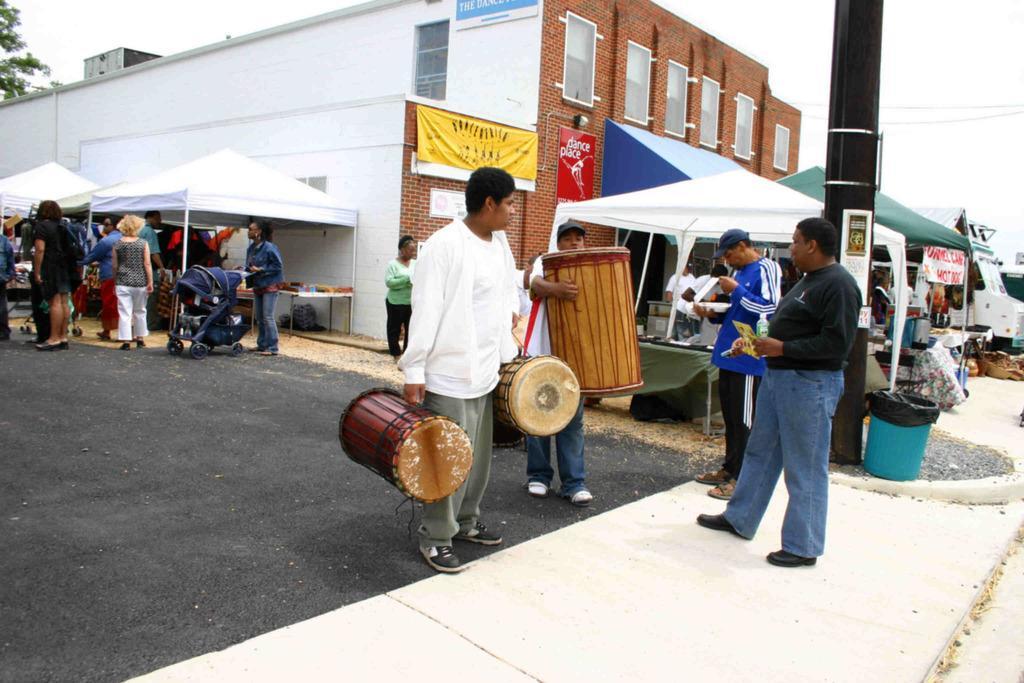Can you describe this image briefly? The image is taken on the streets. In the center of the image there are two people they are holding drums in their hands we can see many people in the background. There are tents, boards and a truck. In the background there is a building, tree and a sky. 